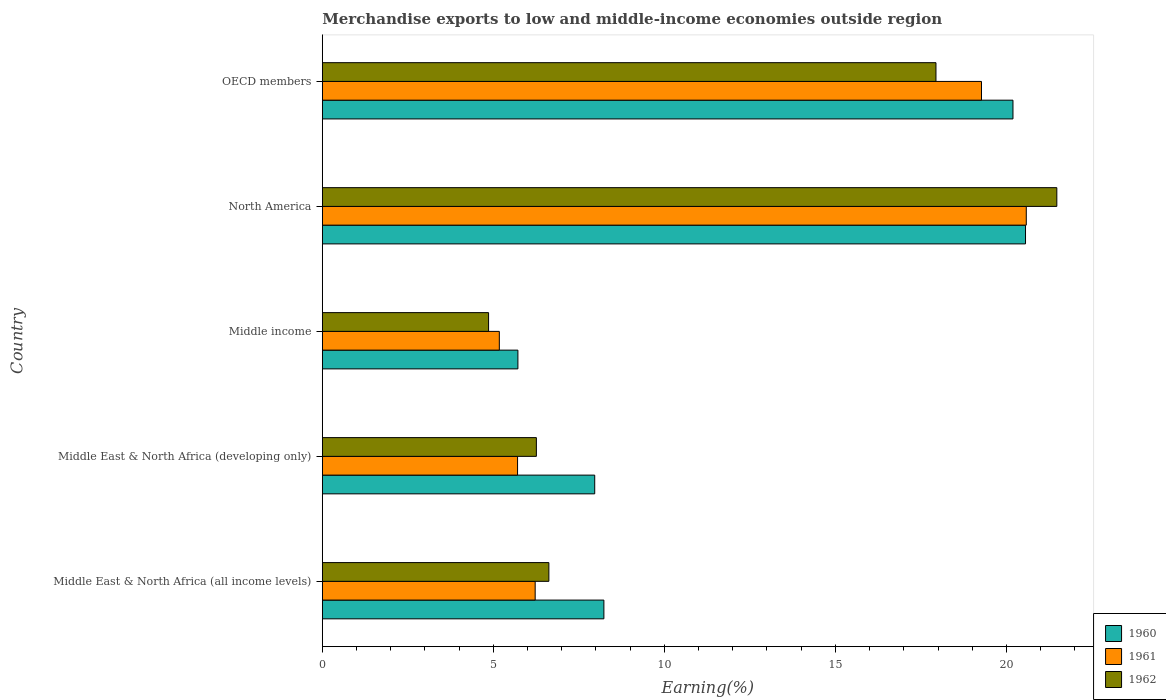How many bars are there on the 2nd tick from the top?
Ensure brevity in your answer.  3. What is the label of the 5th group of bars from the top?
Make the answer very short. Middle East & North Africa (all income levels). In how many cases, is the number of bars for a given country not equal to the number of legend labels?
Give a very brief answer. 0. What is the percentage of amount earned from merchandise exports in 1962 in Middle East & North Africa (all income levels)?
Keep it short and to the point. 6.62. Across all countries, what is the maximum percentage of amount earned from merchandise exports in 1960?
Your answer should be very brief. 20.56. Across all countries, what is the minimum percentage of amount earned from merchandise exports in 1960?
Offer a terse response. 5.72. In which country was the percentage of amount earned from merchandise exports in 1960 maximum?
Ensure brevity in your answer.  North America. In which country was the percentage of amount earned from merchandise exports in 1962 minimum?
Ensure brevity in your answer.  Middle income. What is the total percentage of amount earned from merchandise exports in 1960 in the graph?
Ensure brevity in your answer.  62.66. What is the difference between the percentage of amount earned from merchandise exports in 1960 in Middle income and that in North America?
Ensure brevity in your answer.  -14.84. What is the difference between the percentage of amount earned from merchandise exports in 1961 in Middle East & North Africa (developing only) and the percentage of amount earned from merchandise exports in 1960 in Middle East & North Africa (all income levels)?
Ensure brevity in your answer.  -2.52. What is the average percentage of amount earned from merchandise exports in 1962 per country?
Provide a short and direct response. 11.43. What is the difference between the percentage of amount earned from merchandise exports in 1961 and percentage of amount earned from merchandise exports in 1960 in Middle income?
Keep it short and to the point. -0.54. In how many countries, is the percentage of amount earned from merchandise exports in 1960 greater than 18 %?
Make the answer very short. 2. What is the ratio of the percentage of amount earned from merchandise exports in 1962 in Middle East & North Africa (all income levels) to that in OECD members?
Provide a succinct answer. 0.37. Is the percentage of amount earned from merchandise exports in 1962 in Middle East & North Africa (developing only) less than that in OECD members?
Provide a short and direct response. Yes. Is the difference between the percentage of amount earned from merchandise exports in 1961 in Middle East & North Africa (developing only) and OECD members greater than the difference between the percentage of amount earned from merchandise exports in 1960 in Middle East & North Africa (developing only) and OECD members?
Offer a terse response. No. What is the difference between the highest and the second highest percentage of amount earned from merchandise exports in 1962?
Keep it short and to the point. 3.53. What is the difference between the highest and the lowest percentage of amount earned from merchandise exports in 1961?
Give a very brief answer. 15.41. In how many countries, is the percentage of amount earned from merchandise exports in 1962 greater than the average percentage of amount earned from merchandise exports in 1962 taken over all countries?
Provide a succinct answer. 2. Is the sum of the percentage of amount earned from merchandise exports in 1960 in Middle East & North Africa (developing only) and North America greater than the maximum percentage of amount earned from merchandise exports in 1962 across all countries?
Provide a short and direct response. Yes. What does the 3rd bar from the top in Middle East & North Africa (all income levels) represents?
Your response must be concise. 1960. What does the 3rd bar from the bottom in North America represents?
Give a very brief answer. 1962. Does the graph contain grids?
Offer a terse response. No. Where does the legend appear in the graph?
Ensure brevity in your answer.  Bottom right. How many legend labels are there?
Your answer should be compact. 3. How are the legend labels stacked?
Provide a short and direct response. Vertical. What is the title of the graph?
Give a very brief answer. Merchandise exports to low and middle-income economies outside region. Does "1987" appear as one of the legend labels in the graph?
Provide a short and direct response. No. What is the label or title of the X-axis?
Keep it short and to the point. Earning(%). What is the Earning(%) in 1960 in Middle East & North Africa (all income levels)?
Offer a very short reply. 8.23. What is the Earning(%) of 1961 in Middle East & North Africa (all income levels)?
Make the answer very short. 6.22. What is the Earning(%) in 1962 in Middle East & North Africa (all income levels)?
Offer a very short reply. 6.62. What is the Earning(%) of 1960 in Middle East & North Africa (developing only)?
Keep it short and to the point. 7.96. What is the Earning(%) in 1961 in Middle East & North Africa (developing only)?
Give a very brief answer. 5.71. What is the Earning(%) in 1962 in Middle East & North Africa (developing only)?
Offer a very short reply. 6.26. What is the Earning(%) of 1960 in Middle income?
Your answer should be very brief. 5.72. What is the Earning(%) of 1961 in Middle income?
Your answer should be very brief. 5.17. What is the Earning(%) of 1962 in Middle income?
Make the answer very short. 4.86. What is the Earning(%) of 1960 in North America?
Ensure brevity in your answer.  20.56. What is the Earning(%) of 1961 in North America?
Your response must be concise. 20.58. What is the Earning(%) of 1962 in North America?
Provide a short and direct response. 21.47. What is the Earning(%) in 1960 in OECD members?
Your answer should be compact. 20.19. What is the Earning(%) in 1961 in OECD members?
Give a very brief answer. 19.27. What is the Earning(%) of 1962 in OECD members?
Offer a very short reply. 17.94. Across all countries, what is the maximum Earning(%) in 1960?
Provide a short and direct response. 20.56. Across all countries, what is the maximum Earning(%) of 1961?
Provide a short and direct response. 20.58. Across all countries, what is the maximum Earning(%) in 1962?
Your answer should be very brief. 21.47. Across all countries, what is the minimum Earning(%) in 1960?
Offer a terse response. 5.72. Across all countries, what is the minimum Earning(%) in 1961?
Provide a short and direct response. 5.17. Across all countries, what is the minimum Earning(%) of 1962?
Give a very brief answer. 4.86. What is the total Earning(%) in 1960 in the graph?
Ensure brevity in your answer.  62.66. What is the total Earning(%) of 1961 in the graph?
Your response must be concise. 56.96. What is the total Earning(%) in 1962 in the graph?
Your answer should be very brief. 57.15. What is the difference between the Earning(%) of 1960 in Middle East & North Africa (all income levels) and that in Middle East & North Africa (developing only)?
Keep it short and to the point. 0.27. What is the difference between the Earning(%) in 1961 in Middle East & North Africa (all income levels) and that in Middle East & North Africa (developing only)?
Ensure brevity in your answer.  0.51. What is the difference between the Earning(%) of 1962 in Middle East & North Africa (all income levels) and that in Middle East & North Africa (developing only)?
Keep it short and to the point. 0.37. What is the difference between the Earning(%) in 1960 in Middle East & North Africa (all income levels) and that in Middle income?
Your answer should be compact. 2.51. What is the difference between the Earning(%) of 1961 in Middle East & North Africa (all income levels) and that in Middle income?
Make the answer very short. 1.05. What is the difference between the Earning(%) in 1962 in Middle East & North Africa (all income levels) and that in Middle income?
Your answer should be very brief. 1.76. What is the difference between the Earning(%) in 1960 in Middle East & North Africa (all income levels) and that in North America?
Give a very brief answer. -12.33. What is the difference between the Earning(%) of 1961 in Middle East & North Africa (all income levels) and that in North America?
Provide a succinct answer. -14.36. What is the difference between the Earning(%) in 1962 in Middle East & North Africa (all income levels) and that in North America?
Your response must be concise. -14.85. What is the difference between the Earning(%) of 1960 in Middle East & North Africa (all income levels) and that in OECD members?
Offer a very short reply. -11.96. What is the difference between the Earning(%) in 1961 in Middle East & North Africa (all income levels) and that in OECD members?
Your response must be concise. -13.05. What is the difference between the Earning(%) of 1962 in Middle East & North Africa (all income levels) and that in OECD members?
Keep it short and to the point. -11.32. What is the difference between the Earning(%) of 1960 in Middle East & North Africa (developing only) and that in Middle income?
Offer a very short reply. 2.25. What is the difference between the Earning(%) of 1961 in Middle East & North Africa (developing only) and that in Middle income?
Make the answer very short. 0.53. What is the difference between the Earning(%) in 1962 in Middle East & North Africa (developing only) and that in Middle income?
Your answer should be very brief. 1.4. What is the difference between the Earning(%) in 1960 in Middle East & North Africa (developing only) and that in North America?
Give a very brief answer. -12.59. What is the difference between the Earning(%) in 1961 in Middle East & North Africa (developing only) and that in North America?
Give a very brief answer. -14.87. What is the difference between the Earning(%) of 1962 in Middle East & North Africa (developing only) and that in North America?
Provide a succinct answer. -15.22. What is the difference between the Earning(%) in 1960 in Middle East & North Africa (developing only) and that in OECD members?
Offer a very short reply. -12.23. What is the difference between the Earning(%) in 1961 in Middle East & North Africa (developing only) and that in OECD members?
Your answer should be very brief. -13.56. What is the difference between the Earning(%) in 1962 in Middle East & North Africa (developing only) and that in OECD members?
Provide a short and direct response. -11.68. What is the difference between the Earning(%) in 1960 in Middle income and that in North America?
Give a very brief answer. -14.84. What is the difference between the Earning(%) in 1961 in Middle income and that in North America?
Your response must be concise. -15.41. What is the difference between the Earning(%) of 1962 in Middle income and that in North America?
Provide a short and direct response. -16.61. What is the difference between the Earning(%) in 1960 in Middle income and that in OECD members?
Provide a short and direct response. -14.47. What is the difference between the Earning(%) in 1961 in Middle income and that in OECD members?
Your answer should be compact. -14.1. What is the difference between the Earning(%) in 1962 in Middle income and that in OECD members?
Your answer should be compact. -13.08. What is the difference between the Earning(%) in 1960 in North America and that in OECD members?
Provide a succinct answer. 0.37. What is the difference between the Earning(%) of 1961 in North America and that in OECD members?
Your response must be concise. 1.31. What is the difference between the Earning(%) of 1962 in North America and that in OECD members?
Offer a very short reply. 3.53. What is the difference between the Earning(%) of 1960 in Middle East & North Africa (all income levels) and the Earning(%) of 1961 in Middle East & North Africa (developing only)?
Offer a terse response. 2.52. What is the difference between the Earning(%) in 1960 in Middle East & North Africa (all income levels) and the Earning(%) in 1962 in Middle East & North Africa (developing only)?
Provide a succinct answer. 1.97. What is the difference between the Earning(%) in 1961 in Middle East & North Africa (all income levels) and the Earning(%) in 1962 in Middle East & North Africa (developing only)?
Give a very brief answer. -0.04. What is the difference between the Earning(%) in 1960 in Middle East & North Africa (all income levels) and the Earning(%) in 1961 in Middle income?
Offer a very short reply. 3.06. What is the difference between the Earning(%) in 1960 in Middle East & North Africa (all income levels) and the Earning(%) in 1962 in Middle income?
Give a very brief answer. 3.37. What is the difference between the Earning(%) in 1961 in Middle East & North Africa (all income levels) and the Earning(%) in 1962 in Middle income?
Provide a short and direct response. 1.36. What is the difference between the Earning(%) in 1960 in Middle East & North Africa (all income levels) and the Earning(%) in 1961 in North America?
Make the answer very short. -12.35. What is the difference between the Earning(%) of 1960 in Middle East & North Africa (all income levels) and the Earning(%) of 1962 in North America?
Give a very brief answer. -13.24. What is the difference between the Earning(%) of 1961 in Middle East & North Africa (all income levels) and the Earning(%) of 1962 in North America?
Provide a succinct answer. -15.25. What is the difference between the Earning(%) in 1960 in Middle East & North Africa (all income levels) and the Earning(%) in 1961 in OECD members?
Make the answer very short. -11.04. What is the difference between the Earning(%) of 1960 in Middle East & North Africa (all income levels) and the Earning(%) of 1962 in OECD members?
Keep it short and to the point. -9.71. What is the difference between the Earning(%) in 1961 in Middle East & North Africa (all income levels) and the Earning(%) in 1962 in OECD members?
Offer a terse response. -11.72. What is the difference between the Earning(%) of 1960 in Middle East & North Africa (developing only) and the Earning(%) of 1961 in Middle income?
Your response must be concise. 2.79. What is the difference between the Earning(%) of 1960 in Middle East & North Africa (developing only) and the Earning(%) of 1962 in Middle income?
Your answer should be compact. 3.1. What is the difference between the Earning(%) in 1961 in Middle East & North Africa (developing only) and the Earning(%) in 1962 in Middle income?
Make the answer very short. 0.85. What is the difference between the Earning(%) of 1960 in Middle East & North Africa (developing only) and the Earning(%) of 1961 in North America?
Your answer should be compact. -12.62. What is the difference between the Earning(%) in 1960 in Middle East & North Africa (developing only) and the Earning(%) in 1962 in North America?
Make the answer very short. -13.51. What is the difference between the Earning(%) of 1961 in Middle East & North Africa (developing only) and the Earning(%) of 1962 in North America?
Provide a succinct answer. -15.77. What is the difference between the Earning(%) of 1960 in Middle East & North Africa (developing only) and the Earning(%) of 1961 in OECD members?
Offer a very short reply. -11.31. What is the difference between the Earning(%) in 1960 in Middle East & North Africa (developing only) and the Earning(%) in 1962 in OECD members?
Give a very brief answer. -9.98. What is the difference between the Earning(%) in 1961 in Middle East & North Africa (developing only) and the Earning(%) in 1962 in OECD members?
Provide a succinct answer. -12.23. What is the difference between the Earning(%) in 1960 in Middle income and the Earning(%) in 1961 in North America?
Give a very brief answer. -14.86. What is the difference between the Earning(%) of 1960 in Middle income and the Earning(%) of 1962 in North America?
Your response must be concise. -15.76. What is the difference between the Earning(%) of 1961 in Middle income and the Earning(%) of 1962 in North America?
Provide a succinct answer. -16.3. What is the difference between the Earning(%) of 1960 in Middle income and the Earning(%) of 1961 in OECD members?
Your response must be concise. -13.55. What is the difference between the Earning(%) of 1960 in Middle income and the Earning(%) of 1962 in OECD members?
Provide a short and direct response. -12.22. What is the difference between the Earning(%) of 1961 in Middle income and the Earning(%) of 1962 in OECD members?
Provide a succinct answer. -12.77. What is the difference between the Earning(%) in 1960 in North America and the Earning(%) in 1961 in OECD members?
Your answer should be very brief. 1.29. What is the difference between the Earning(%) in 1960 in North America and the Earning(%) in 1962 in OECD members?
Keep it short and to the point. 2.62. What is the difference between the Earning(%) in 1961 in North America and the Earning(%) in 1962 in OECD members?
Keep it short and to the point. 2.64. What is the average Earning(%) of 1960 per country?
Offer a very short reply. 12.53. What is the average Earning(%) of 1961 per country?
Your response must be concise. 11.39. What is the average Earning(%) in 1962 per country?
Provide a succinct answer. 11.43. What is the difference between the Earning(%) of 1960 and Earning(%) of 1961 in Middle East & North Africa (all income levels)?
Offer a terse response. 2.01. What is the difference between the Earning(%) of 1960 and Earning(%) of 1962 in Middle East & North Africa (all income levels)?
Ensure brevity in your answer.  1.61. What is the difference between the Earning(%) of 1961 and Earning(%) of 1962 in Middle East & North Africa (all income levels)?
Make the answer very short. -0.4. What is the difference between the Earning(%) in 1960 and Earning(%) in 1961 in Middle East & North Africa (developing only)?
Provide a short and direct response. 2.26. What is the difference between the Earning(%) in 1960 and Earning(%) in 1962 in Middle East & North Africa (developing only)?
Offer a terse response. 1.71. What is the difference between the Earning(%) of 1961 and Earning(%) of 1962 in Middle East & North Africa (developing only)?
Ensure brevity in your answer.  -0.55. What is the difference between the Earning(%) of 1960 and Earning(%) of 1961 in Middle income?
Offer a terse response. 0.54. What is the difference between the Earning(%) in 1960 and Earning(%) in 1962 in Middle income?
Your response must be concise. 0.86. What is the difference between the Earning(%) in 1961 and Earning(%) in 1962 in Middle income?
Your answer should be compact. 0.31. What is the difference between the Earning(%) of 1960 and Earning(%) of 1961 in North America?
Offer a very short reply. -0.02. What is the difference between the Earning(%) in 1960 and Earning(%) in 1962 in North America?
Your answer should be very brief. -0.92. What is the difference between the Earning(%) in 1961 and Earning(%) in 1962 in North America?
Keep it short and to the point. -0.89. What is the difference between the Earning(%) in 1960 and Earning(%) in 1961 in OECD members?
Your answer should be very brief. 0.92. What is the difference between the Earning(%) of 1960 and Earning(%) of 1962 in OECD members?
Provide a succinct answer. 2.25. What is the difference between the Earning(%) in 1961 and Earning(%) in 1962 in OECD members?
Your answer should be compact. 1.33. What is the ratio of the Earning(%) in 1960 in Middle East & North Africa (all income levels) to that in Middle East & North Africa (developing only)?
Offer a very short reply. 1.03. What is the ratio of the Earning(%) in 1961 in Middle East & North Africa (all income levels) to that in Middle East & North Africa (developing only)?
Offer a very short reply. 1.09. What is the ratio of the Earning(%) in 1962 in Middle East & North Africa (all income levels) to that in Middle East & North Africa (developing only)?
Provide a short and direct response. 1.06. What is the ratio of the Earning(%) in 1960 in Middle East & North Africa (all income levels) to that in Middle income?
Give a very brief answer. 1.44. What is the ratio of the Earning(%) in 1961 in Middle East & North Africa (all income levels) to that in Middle income?
Your answer should be compact. 1.2. What is the ratio of the Earning(%) in 1962 in Middle East & North Africa (all income levels) to that in Middle income?
Your answer should be very brief. 1.36. What is the ratio of the Earning(%) of 1960 in Middle East & North Africa (all income levels) to that in North America?
Give a very brief answer. 0.4. What is the ratio of the Earning(%) in 1961 in Middle East & North Africa (all income levels) to that in North America?
Your answer should be very brief. 0.3. What is the ratio of the Earning(%) of 1962 in Middle East & North Africa (all income levels) to that in North America?
Give a very brief answer. 0.31. What is the ratio of the Earning(%) of 1960 in Middle East & North Africa (all income levels) to that in OECD members?
Your response must be concise. 0.41. What is the ratio of the Earning(%) in 1961 in Middle East & North Africa (all income levels) to that in OECD members?
Provide a short and direct response. 0.32. What is the ratio of the Earning(%) of 1962 in Middle East & North Africa (all income levels) to that in OECD members?
Provide a succinct answer. 0.37. What is the ratio of the Earning(%) of 1960 in Middle East & North Africa (developing only) to that in Middle income?
Ensure brevity in your answer.  1.39. What is the ratio of the Earning(%) in 1961 in Middle East & North Africa (developing only) to that in Middle income?
Offer a very short reply. 1.1. What is the ratio of the Earning(%) in 1962 in Middle East & North Africa (developing only) to that in Middle income?
Your answer should be compact. 1.29. What is the ratio of the Earning(%) of 1960 in Middle East & North Africa (developing only) to that in North America?
Your answer should be very brief. 0.39. What is the ratio of the Earning(%) of 1961 in Middle East & North Africa (developing only) to that in North America?
Offer a terse response. 0.28. What is the ratio of the Earning(%) of 1962 in Middle East & North Africa (developing only) to that in North America?
Offer a terse response. 0.29. What is the ratio of the Earning(%) of 1960 in Middle East & North Africa (developing only) to that in OECD members?
Offer a very short reply. 0.39. What is the ratio of the Earning(%) of 1961 in Middle East & North Africa (developing only) to that in OECD members?
Provide a succinct answer. 0.3. What is the ratio of the Earning(%) in 1962 in Middle East & North Africa (developing only) to that in OECD members?
Your answer should be very brief. 0.35. What is the ratio of the Earning(%) of 1960 in Middle income to that in North America?
Give a very brief answer. 0.28. What is the ratio of the Earning(%) in 1961 in Middle income to that in North America?
Provide a succinct answer. 0.25. What is the ratio of the Earning(%) of 1962 in Middle income to that in North America?
Your response must be concise. 0.23. What is the ratio of the Earning(%) in 1960 in Middle income to that in OECD members?
Ensure brevity in your answer.  0.28. What is the ratio of the Earning(%) in 1961 in Middle income to that in OECD members?
Provide a succinct answer. 0.27. What is the ratio of the Earning(%) of 1962 in Middle income to that in OECD members?
Your response must be concise. 0.27. What is the ratio of the Earning(%) in 1960 in North America to that in OECD members?
Keep it short and to the point. 1.02. What is the ratio of the Earning(%) of 1961 in North America to that in OECD members?
Ensure brevity in your answer.  1.07. What is the ratio of the Earning(%) in 1962 in North America to that in OECD members?
Your answer should be very brief. 1.2. What is the difference between the highest and the second highest Earning(%) of 1960?
Ensure brevity in your answer.  0.37. What is the difference between the highest and the second highest Earning(%) of 1961?
Make the answer very short. 1.31. What is the difference between the highest and the second highest Earning(%) of 1962?
Provide a short and direct response. 3.53. What is the difference between the highest and the lowest Earning(%) in 1960?
Your answer should be very brief. 14.84. What is the difference between the highest and the lowest Earning(%) of 1961?
Give a very brief answer. 15.41. What is the difference between the highest and the lowest Earning(%) of 1962?
Your answer should be very brief. 16.61. 